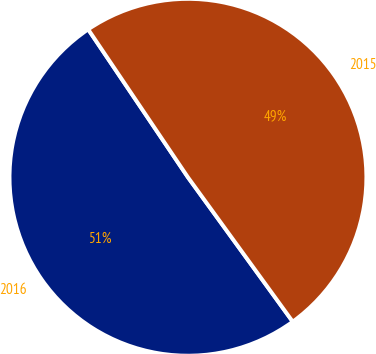Convert chart. <chart><loc_0><loc_0><loc_500><loc_500><pie_chart><fcel>2016<fcel>2015<nl><fcel>50.55%<fcel>49.45%<nl></chart> 